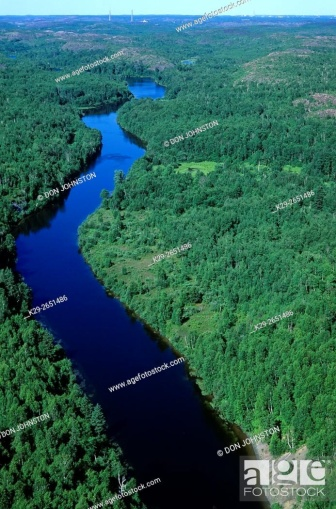Explain the visual content of the image in great detail.
 The image captures a breathtaking aerial view of a winding river, snaking its way through a lush forest. The river, a deep shade of blue, stands out against the verdant greenery of the surrounding trees. The forest is a mix of coniferous and deciduous trees, their varying shades of green creating a beautiful mosaic of nature's palette. The river appears to be quite wide, its expanse visible even from the high vantage point of the image. The image is devoid of any human presence or man-made structures, offering a pristine view of nature in its raw form. The high-angle perspective provides a bird's-eye view of the river and the forest, emphasizing the vastness of the landscape. The image is a testament to the beauty and grandeur of nature, untouched and unspoiled. 